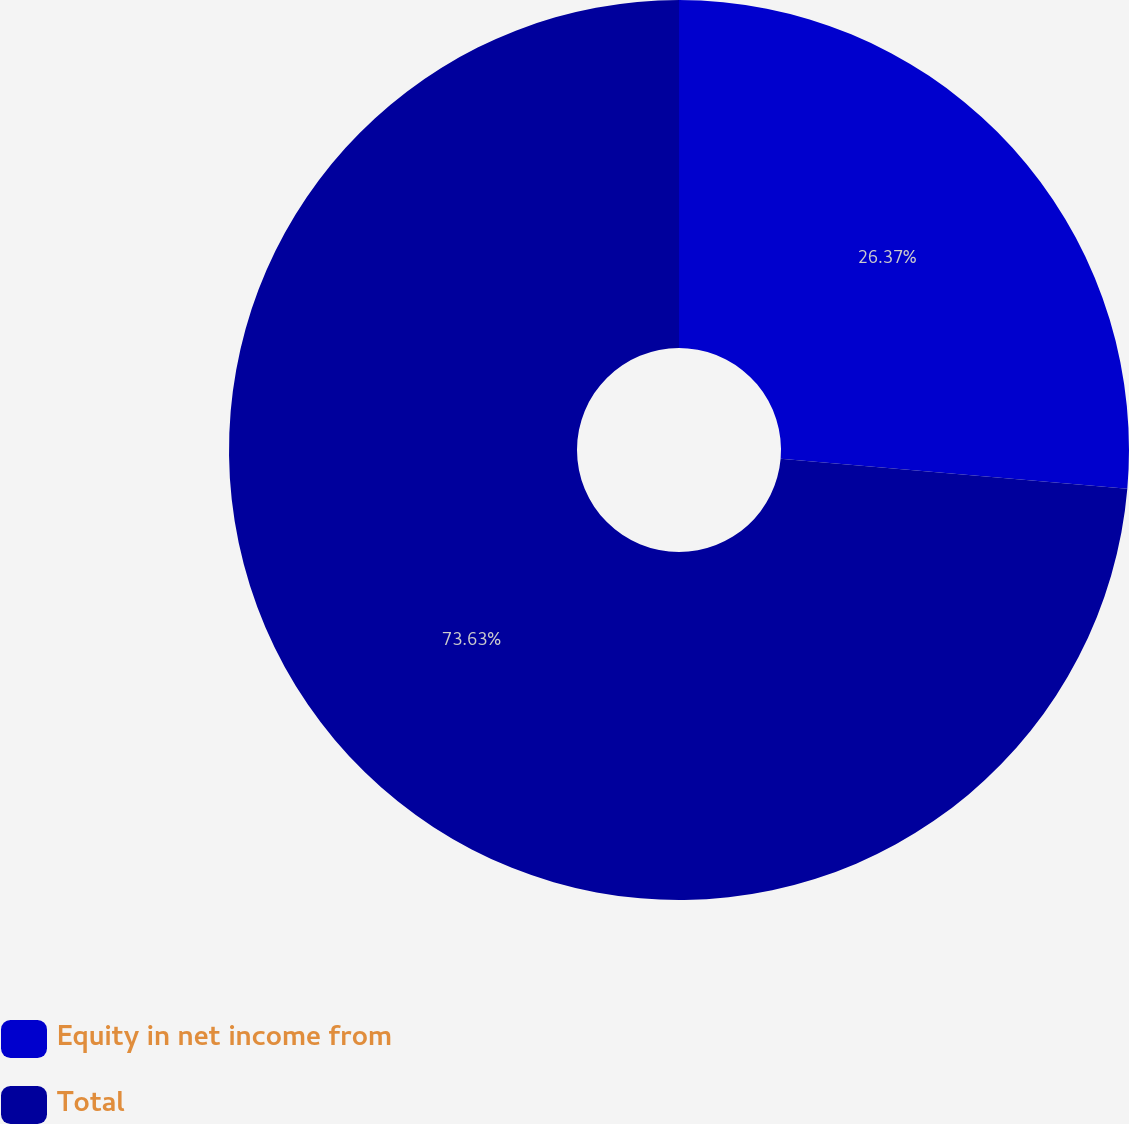<chart> <loc_0><loc_0><loc_500><loc_500><pie_chart><fcel>Equity in net income from<fcel>Total<nl><fcel>26.37%<fcel>73.63%<nl></chart> 